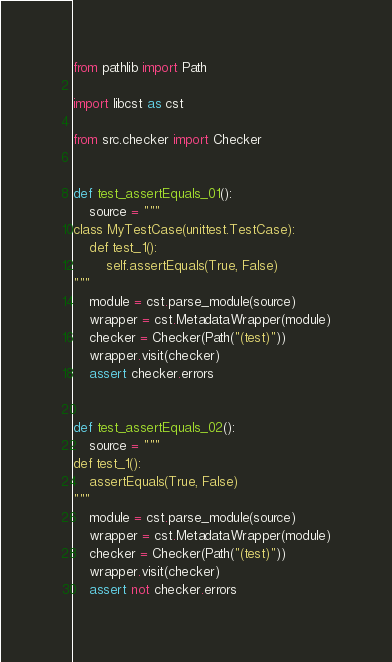Convert code to text. <code><loc_0><loc_0><loc_500><loc_500><_Python_>from pathlib import Path

import libcst as cst

from src.checker import Checker


def test_assertEquals_01():
    source = """
class MyTestCase(unittest.TestCase):
    def test_1():
        self.assertEquals(True, False)
"""
    module = cst.parse_module(source)
    wrapper = cst.MetadataWrapper(module)
    checker = Checker(Path("(test)"))
    wrapper.visit(checker)
    assert checker.errors


def test_assertEquals_02():
    source = """
def test_1():
    assertEquals(True, False)
"""
    module = cst.parse_module(source)
    wrapper = cst.MetadataWrapper(module)
    checker = Checker(Path("(test)"))
    wrapper.visit(checker)
    assert not checker.errors
</code> 